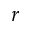<formula> <loc_0><loc_0><loc_500><loc_500>r</formula> 